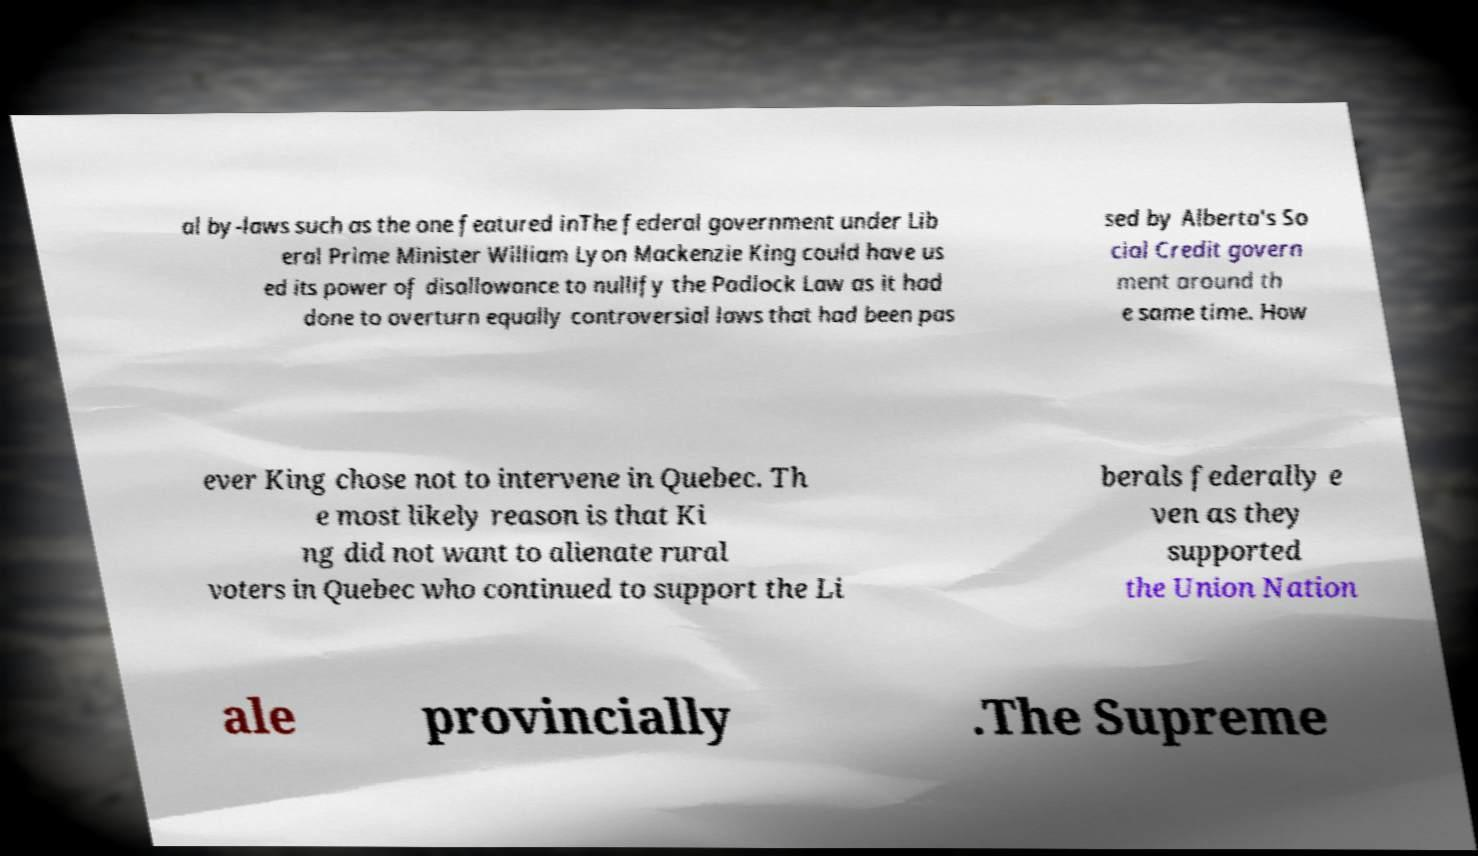For documentation purposes, I need the text within this image transcribed. Could you provide that? al by-laws such as the one featured inThe federal government under Lib eral Prime Minister William Lyon Mackenzie King could have us ed its power of disallowance to nullify the Padlock Law as it had done to overturn equally controversial laws that had been pas sed by Alberta's So cial Credit govern ment around th e same time. How ever King chose not to intervene in Quebec. Th e most likely reason is that Ki ng did not want to alienate rural voters in Quebec who continued to support the Li berals federally e ven as they supported the Union Nation ale provincially .The Supreme 